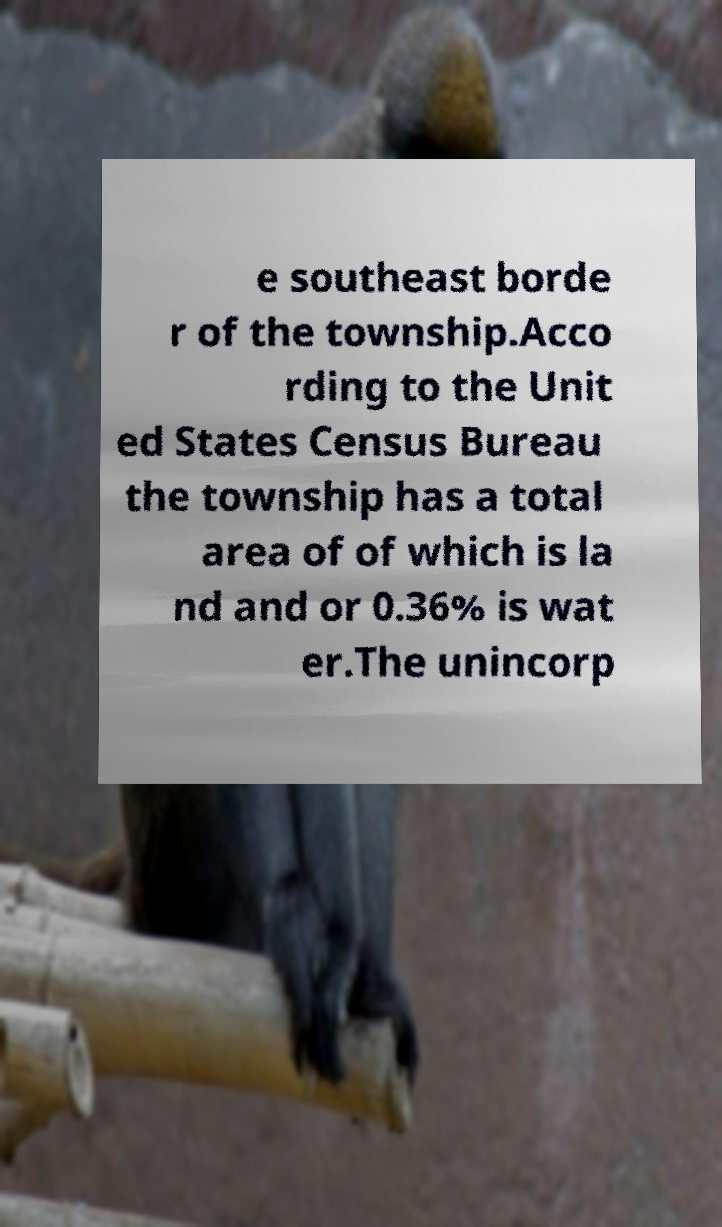Please read and relay the text visible in this image. What does it say? e southeast borde r of the township.Acco rding to the Unit ed States Census Bureau the township has a total area of of which is la nd and or 0.36% is wat er.The unincorp 